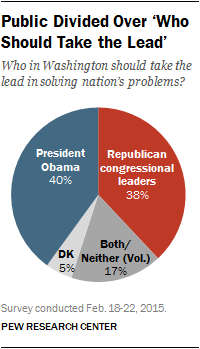Mention a couple of crucial points in this snapshot. It is widely believed that President Obama is the most popularly held opinion. The red pie represents Republican congressional leaders. 